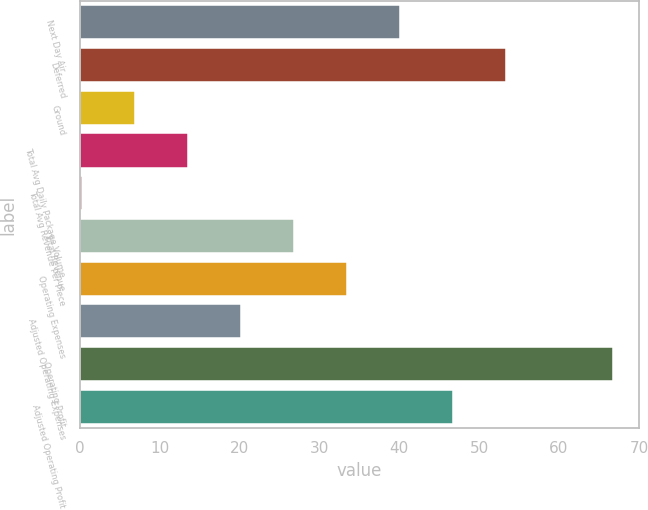Convert chart. <chart><loc_0><loc_0><loc_500><loc_500><bar_chart><fcel>Next Day Air<fcel>Deferred<fcel>Ground<fcel>Total Avg Daily Package Volume<fcel>Total Avg Revenue Per Piece<fcel>Total Revenue<fcel>Operating Expenses<fcel>Adjusted Operating Expenses<fcel>Operating Profit<fcel>Adjusted Operating Profit<nl><fcel>40.14<fcel>53.42<fcel>6.94<fcel>13.58<fcel>0.3<fcel>26.86<fcel>33.5<fcel>20.22<fcel>66.7<fcel>46.78<nl></chart> 